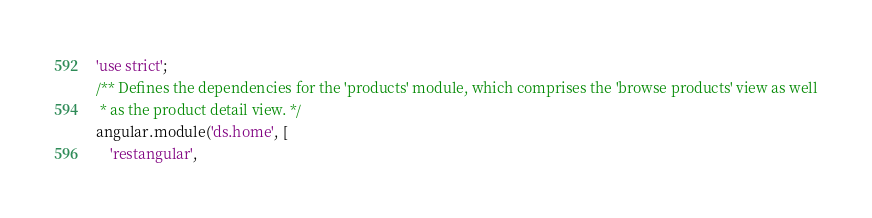Convert code to text. <code><loc_0><loc_0><loc_500><loc_500><_JavaScript_>'use strict';
/** Defines the dependencies for the 'products' module, which comprises the 'browse products' view as well
 * as the product detail view. */
angular.module('ds.home', [
    'restangular',</code> 